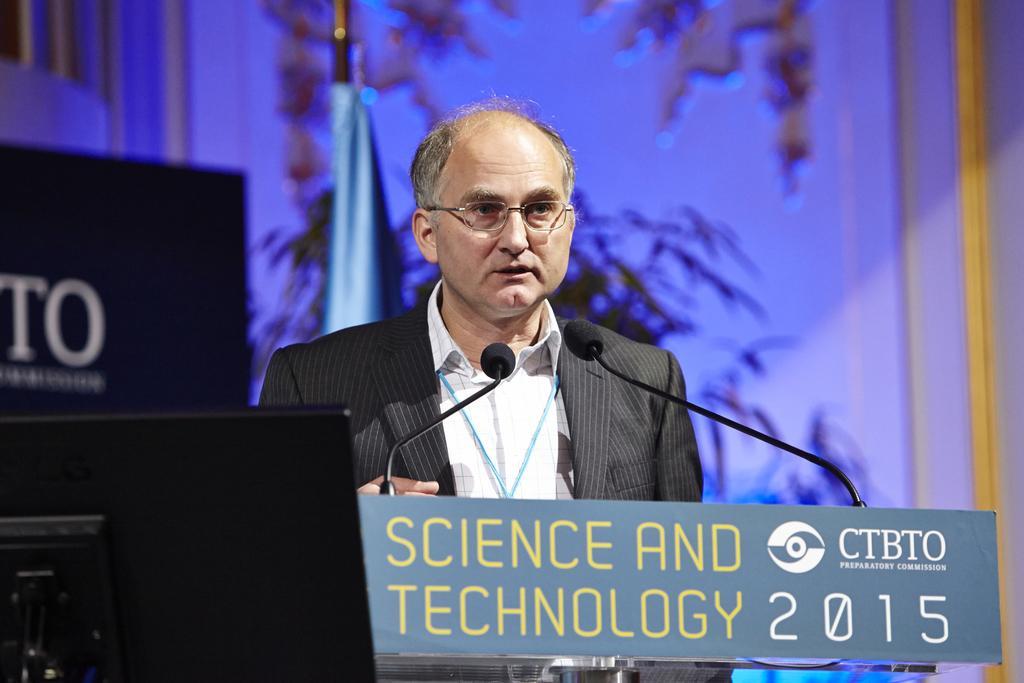Please provide a concise description of this image. In this image I can see the person standing in-front of the podium. And there are mics and I can see the board on the podium. On the board there is a text science and technology is written. To the left I can see another board. In the background there is a wall. 